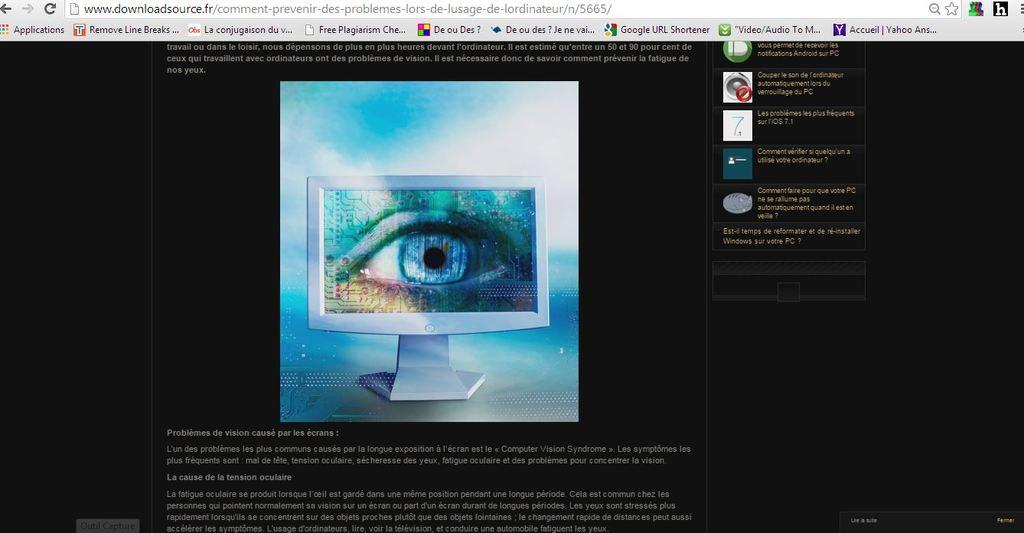<image>
Describe the image concisely. A web browser is opened to the French downloadsource page. 